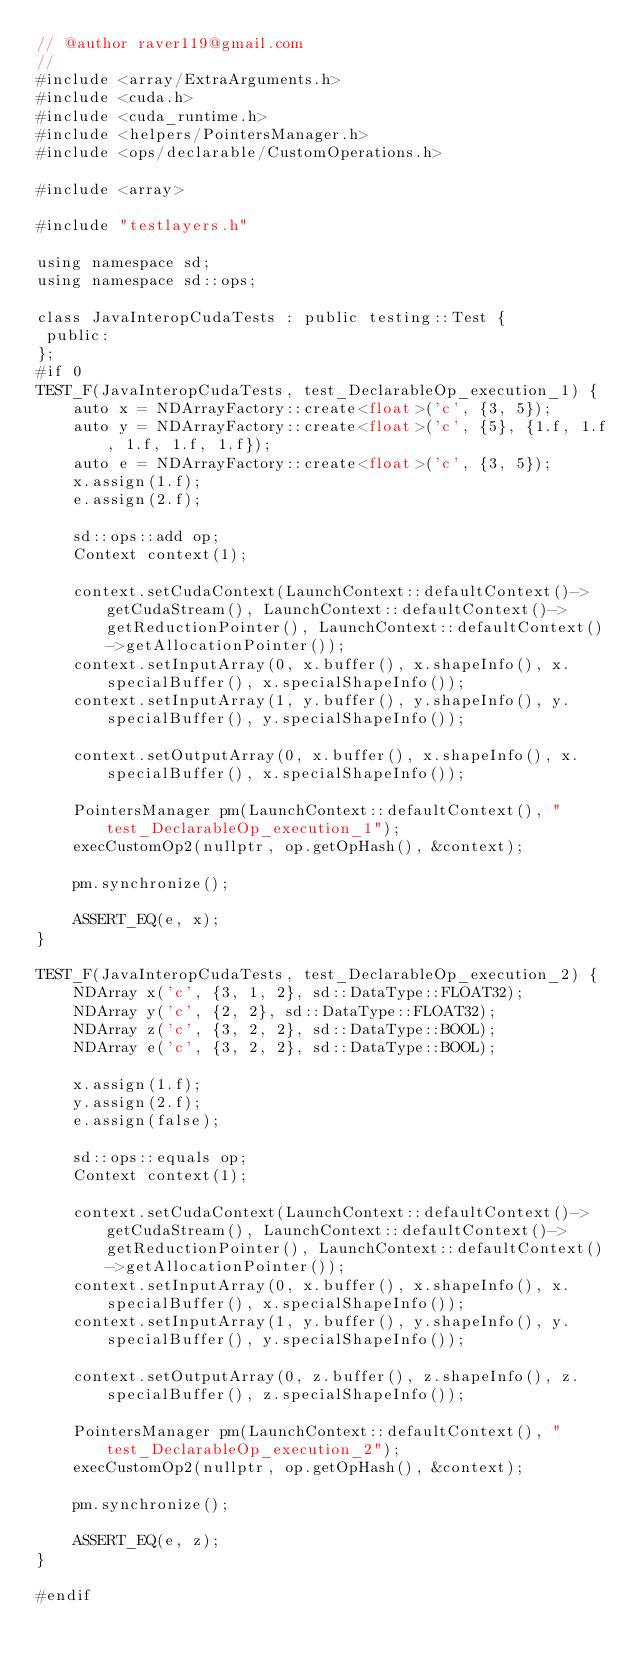<code> <loc_0><loc_0><loc_500><loc_500><_Cuda_>// @author raver119@gmail.com
//
#include <array/ExtraArguments.h>
#include <cuda.h>
#include <cuda_runtime.h>
#include <helpers/PointersManager.h>
#include <ops/declarable/CustomOperations.h>

#include <array>

#include "testlayers.h"

using namespace sd;
using namespace sd::ops;

class JavaInteropCudaTests : public testing::Test {
 public:
};
#if 0
TEST_F(JavaInteropCudaTests, test_DeclarableOp_execution_1) {
    auto x = NDArrayFactory::create<float>('c', {3, 5});
    auto y = NDArrayFactory::create<float>('c', {5}, {1.f, 1.f, 1.f, 1.f, 1.f});
    auto e = NDArrayFactory::create<float>('c', {3, 5});
    x.assign(1.f);
    e.assign(2.f);

    sd::ops::add op;
    Context context(1);

    context.setCudaContext(LaunchContext::defaultContext()->getCudaStream(), LaunchContext::defaultContext()->getReductionPointer(), LaunchContext::defaultContext()->getAllocationPointer());
    context.setInputArray(0, x.buffer(), x.shapeInfo(), x.specialBuffer(), x.specialShapeInfo());
    context.setInputArray(1, y.buffer(), y.shapeInfo(), y.specialBuffer(), y.specialShapeInfo());

    context.setOutputArray(0, x.buffer(), x.shapeInfo(), x.specialBuffer(), x.specialShapeInfo());

    PointersManager pm(LaunchContext::defaultContext(), "test_DeclarableOp_execution_1");
    execCustomOp2(nullptr, op.getOpHash(), &context);

    pm.synchronize();

    ASSERT_EQ(e, x);
}

TEST_F(JavaInteropCudaTests, test_DeclarableOp_execution_2) {
    NDArray x('c', {3, 1, 2}, sd::DataType::FLOAT32);
    NDArray y('c', {2, 2}, sd::DataType::FLOAT32);
    NDArray z('c', {3, 2, 2}, sd::DataType::BOOL);
    NDArray e('c', {3, 2, 2}, sd::DataType::BOOL);

    x.assign(1.f);
    y.assign(2.f);
    e.assign(false);

    sd::ops::equals op;
    Context context(1);

    context.setCudaContext(LaunchContext::defaultContext()->getCudaStream(), LaunchContext::defaultContext()->getReductionPointer(), LaunchContext::defaultContext()->getAllocationPointer());
    context.setInputArray(0, x.buffer(), x.shapeInfo(), x.specialBuffer(), x.specialShapeInfo());
    context.setInputArray(1, y.buffer(), y.shapeInfo(), y.specialBuffer(), y.specialShapeInfo());

    context.setOutputArray(0, z.buffer(), z.shapeInfo(), z.specialBuffer(), z.specialShapeInfo());

    PointersManager pm(LaunchContext::defaultContext(), "test_DeclarableOp_execution_2");
    execCustomOp2(nullptr, op.getOpHash(), &context);

    pm.synchronize();

    ASSERT_EQ(e, z);
}

#endif
</code> 